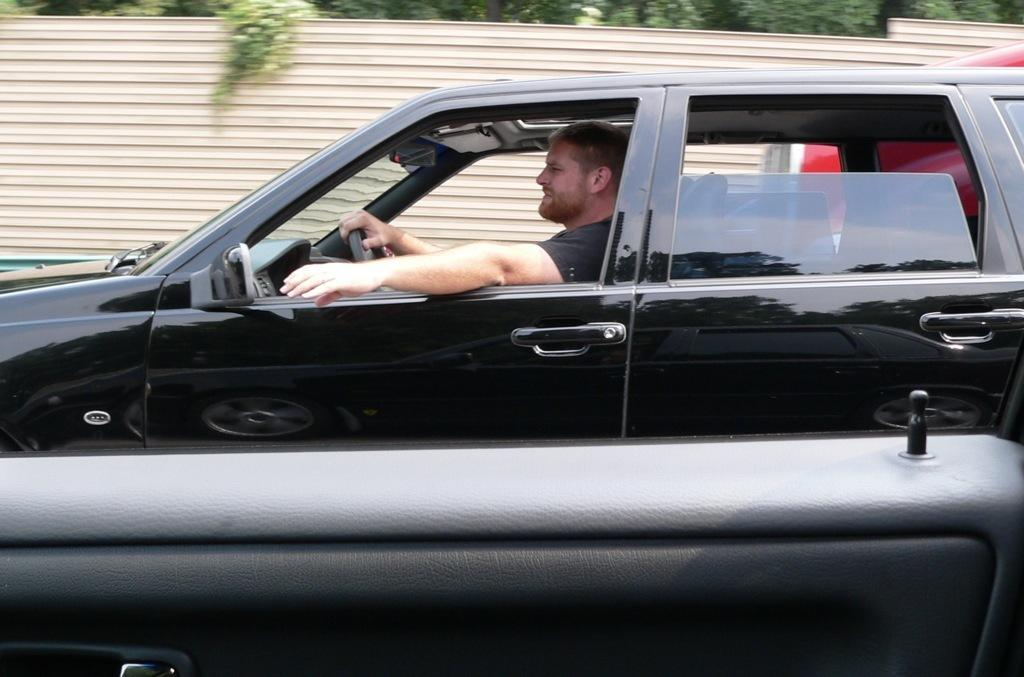Who is present in the image? There is a man in the image. What is the man doing in the image? The man is riding a black car in the image. What can be seen in the background of the image? There is a fence and trees in the image. What is the rate of zinc production in the image? There is no information about zinc production in the image, as it features a man riding a black car with a fence and trees in the background. 